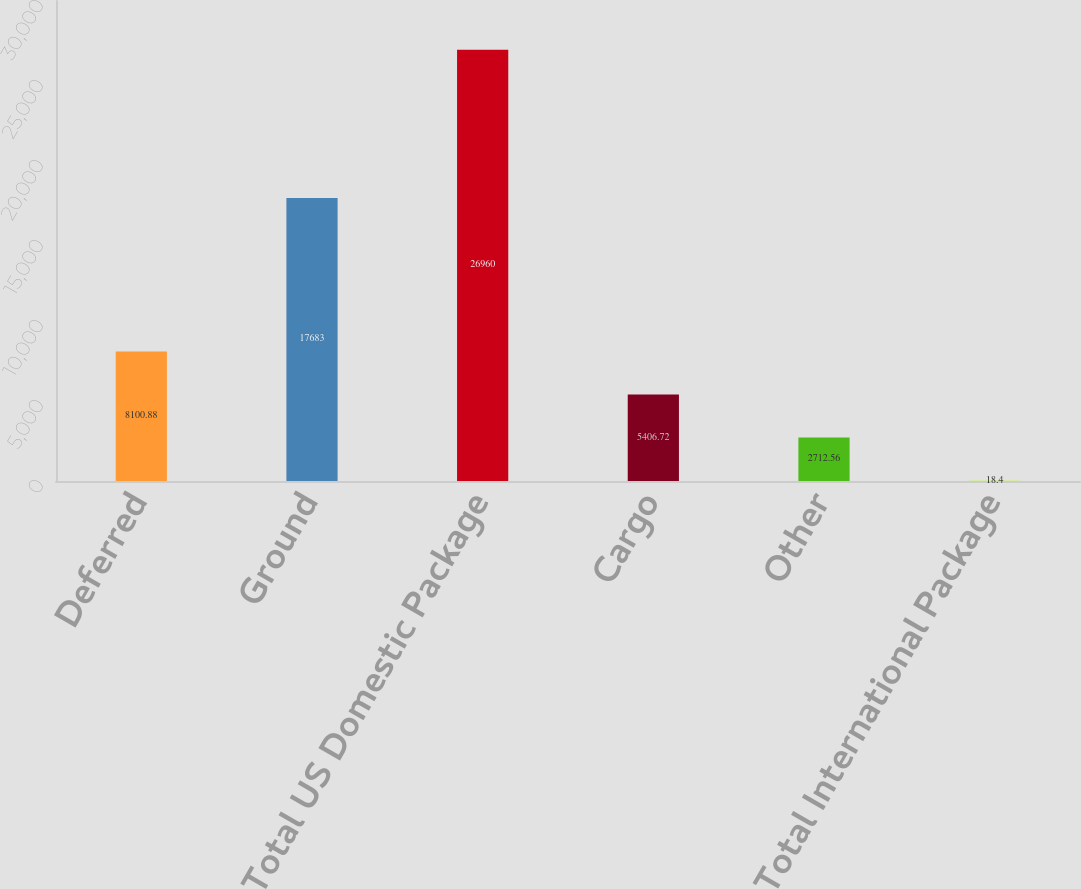<chart> <loc_0><loc_0><loc_500><loc_500><bar_chart><fcel>Deferred<fcel>Ground<fcel>Total US Domestic Package<fcel>Cargo<fcel>Other<fcel>Total International Package<nl><fcel>8100.88<fcel>17683<fcel>26960<fcel>5406.72<fcel>2712.56<fcel>18.4<nl></chart> 